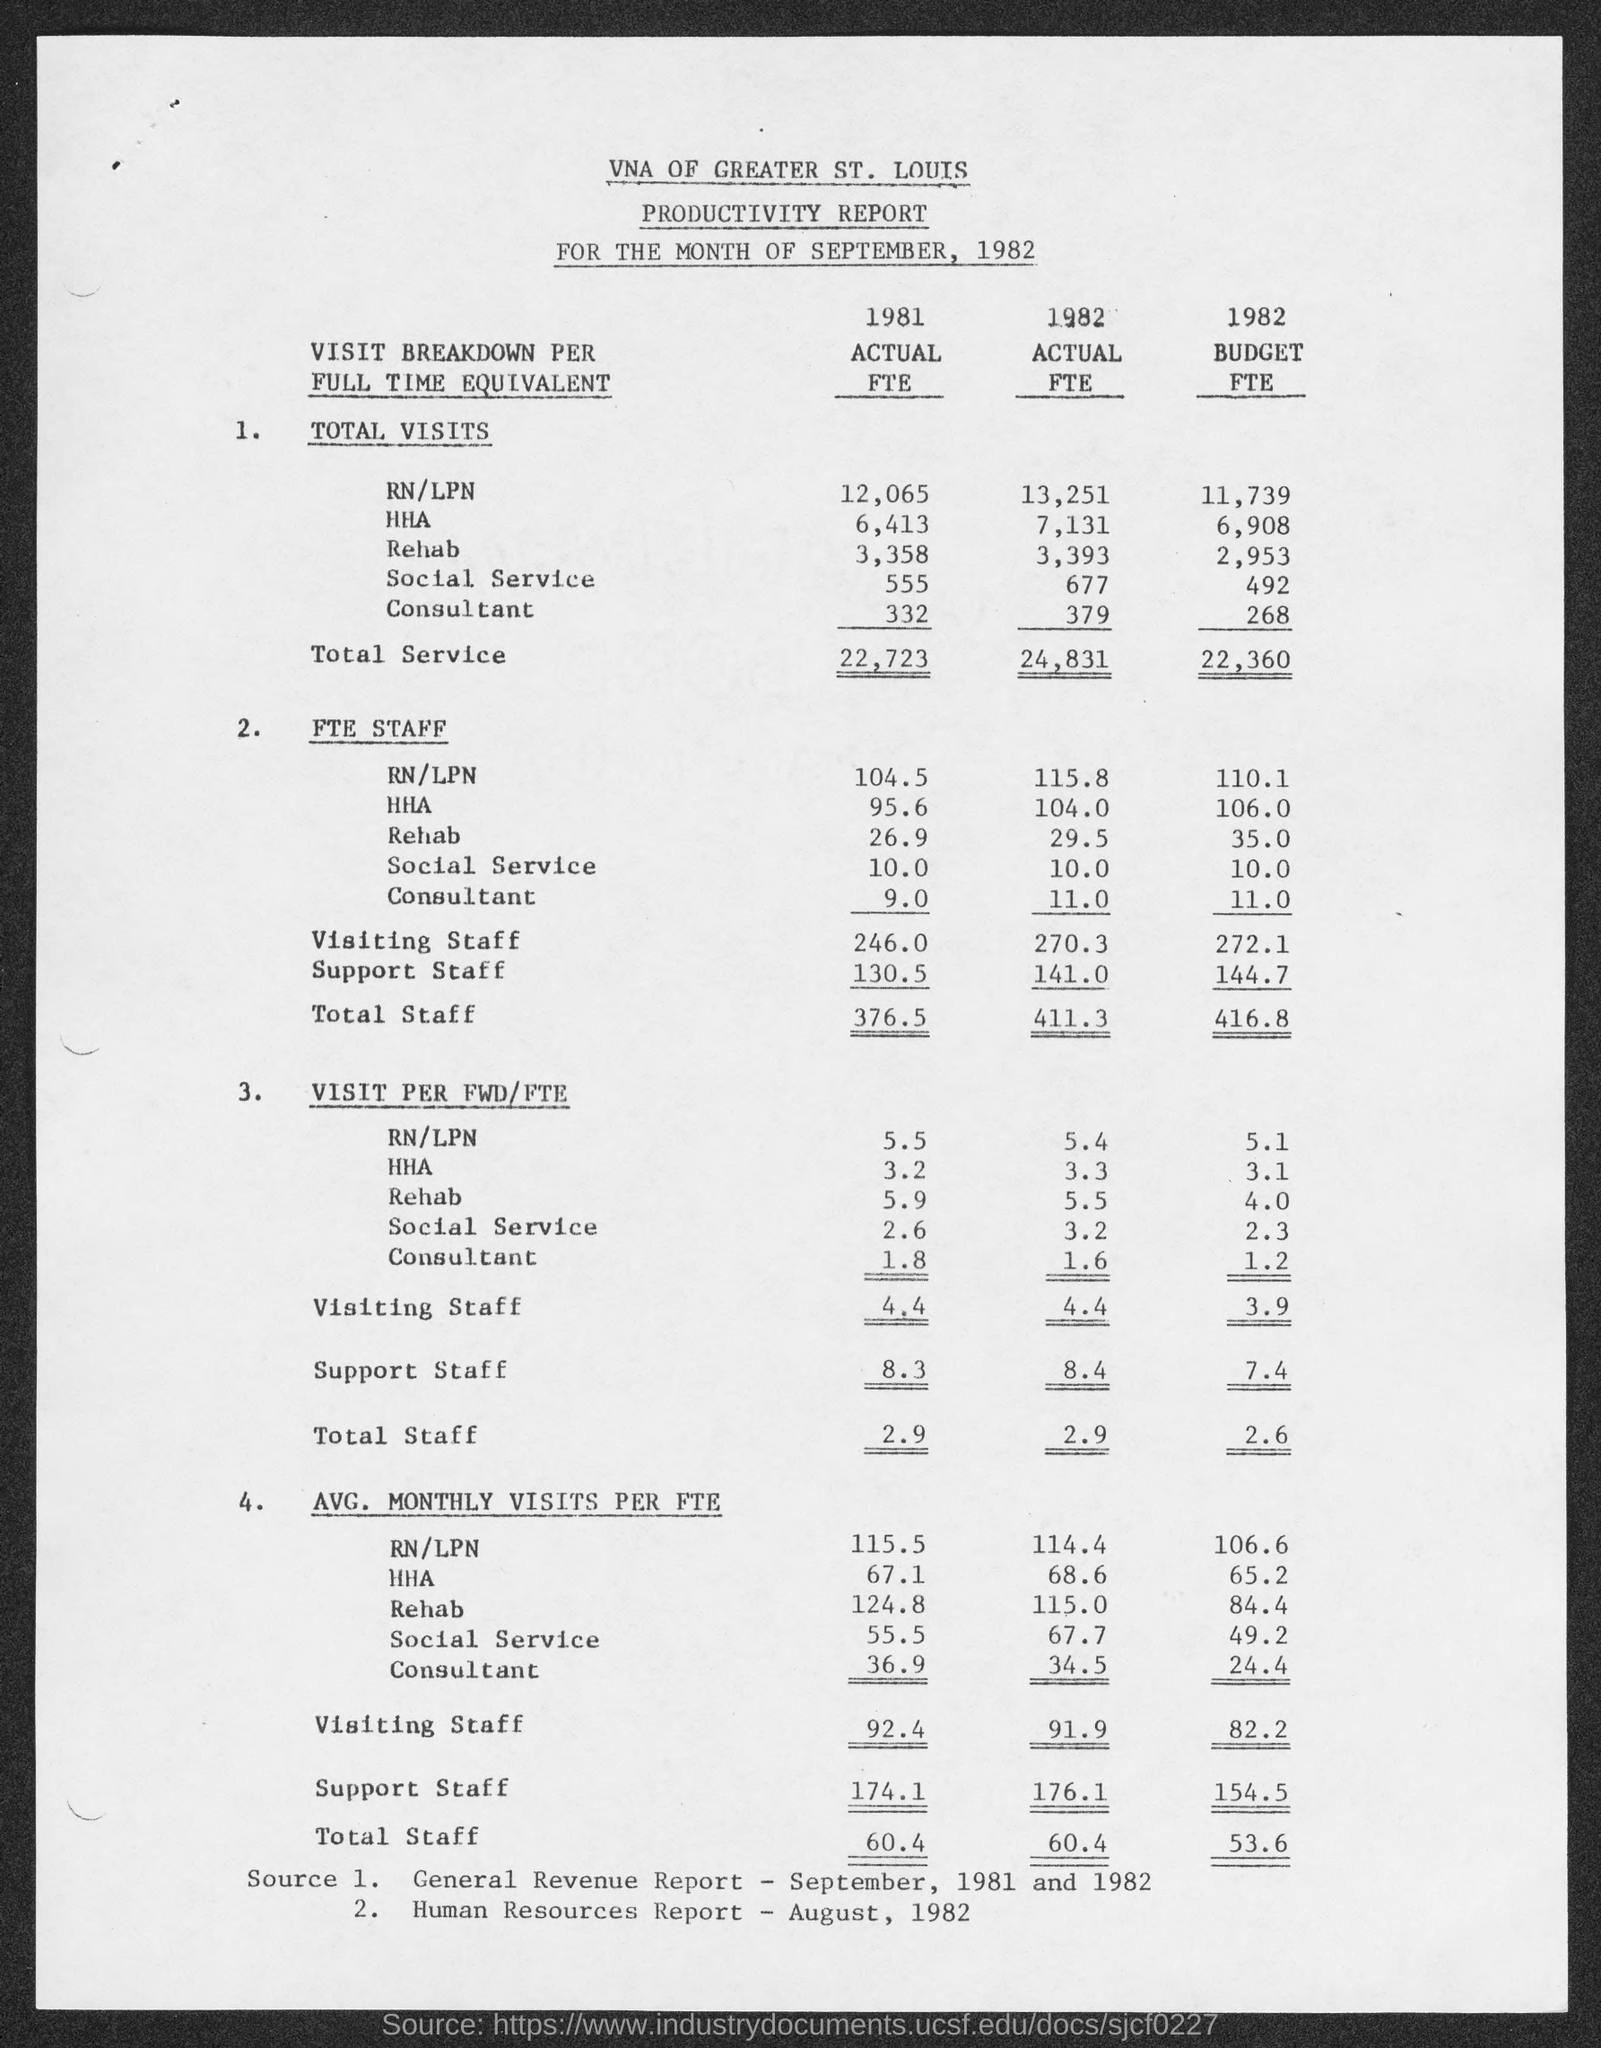What is the total service in actual FTE 1981?
Make the answer very short. 22,723. What is the total FTE staff in 1982 actual FTE?
Make the answer very short. 411.3. 